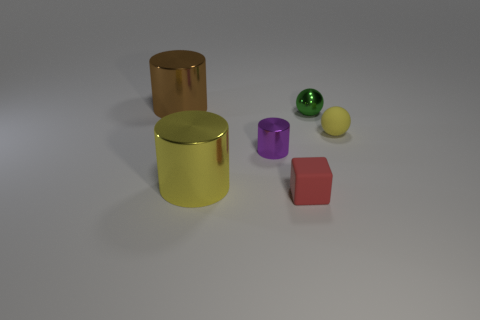Are there the same number of rubber cubes on the right side of the green shiny ball and big purple rubber cylinders?
Offer a terse response. Yes. Is there anything else that has the same shape as the tiny red matte thing?
Your answer should be compact. No. Does the brown thing have the same shape as the matte thing to the right of the tiny red block?
Your answer should be very brief. No. There is a brown metal thing that is the same shape as the purple shiny object; what size is it?
Provide a short and direct response. Large. What number of other objects are there of the same material as the small block?
Offer a very short reply. 1. What is the small purple cylinder made of?
Your response must be concise. Metal. Does the cylinder that is in front of the tiny cylinder have the same color as the tiny rubber thing to the right of the small block?
Give a very brief answer. Yes. Are there more brown cylinders that are left of the red cube than big gray shiny cubes?
Ensure brevity in your answer.  Yes. What number of other things are there of the same color as the rubber sphere?
Ensure brevity in your answer.  1. Do the cylinder that is in front of the purple metallic cylinder and the green ball have the same size?
Offer a terse response. No. 